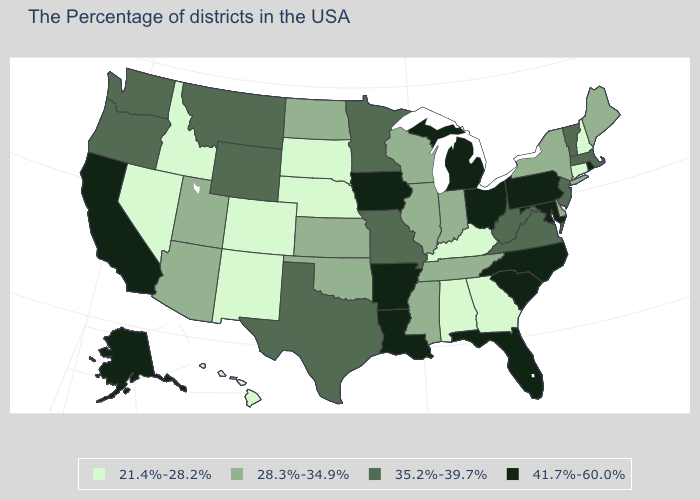Among the states that border Rhode Island , which have the lowest value?
Answer briefly. Connecticut. Name the states that have a value in the range 21.4%-28.2%?
Keep it brief. New Hampshire, Connecticut, Georgia, Kentucky, Alabama, Nebraska, South Dakota, Colorado, New Mexico, Idaho, Nevada, Hawaii. What is the value of Hawaii?
Quick response, please. 21.4%-28.2%. What is the highest value in the USA?
Be succinct. 41.7%-60.0%. Name the states that have a value in the range 21.4%-28.2%?
Write a very short answer. New Hampshire, Connecticut, Georgia, Kentucky, Alabama, Nebraska, South Dakota, Colorado, New Mexico, Idaho, Nevada, Hawaii. Which states have the lowest value in the Northeast?
Concise answer only. New Hampshire, Connecticut. Among the states that border Montana , which have the lowest value?
Quick response, please. South Dakota, Idaho. Is the legend a continuous bar?
Short answer required. No. Name the states that have a value in the range 41.7%-60.0%?
Short answer required. Rhode Island, Maryland, Pennsylvania, North Carolina, South Carolina, Ohio, Florida, Michigan, Louisiana, Arkansas, Iowa, California, Alaska. Name the states that have a value in the range 41.7%-60.0%?
Answer briefly. Rhode Island, Maryland, Pennsylvania, North Carolina, South Carolina, Ohio, Florida, Michigan, Louisiana, Arkansas, Iowa, California, Alaska. Among the states that border Maryland , which have the lowest value?
Write a very short answer. Delaware. Which states have the lowest value in the USA?
Answer briefly. New Hampshire, Connecticut, Georgia, Kentucky, Alabama, Nebraska, South Dakota, Colorado, New Mexico, Idaho, Nevada, Hawaii. What is the value of New York?
Give a very brief answer. 28.3%-34.9%. What is the lowest value in states that border Florida?
Give a very brief answer. 21.4%-28.2%. Name the states that have a value in the range 28.3%-34.9%?
Write a very short answer. Maine, New York, Delaware, Indiana, Tennessee, Wisconsin, Illinois, Mississippi, Kansas, Oklahoma, North Dakota, Utah, Arizona. 